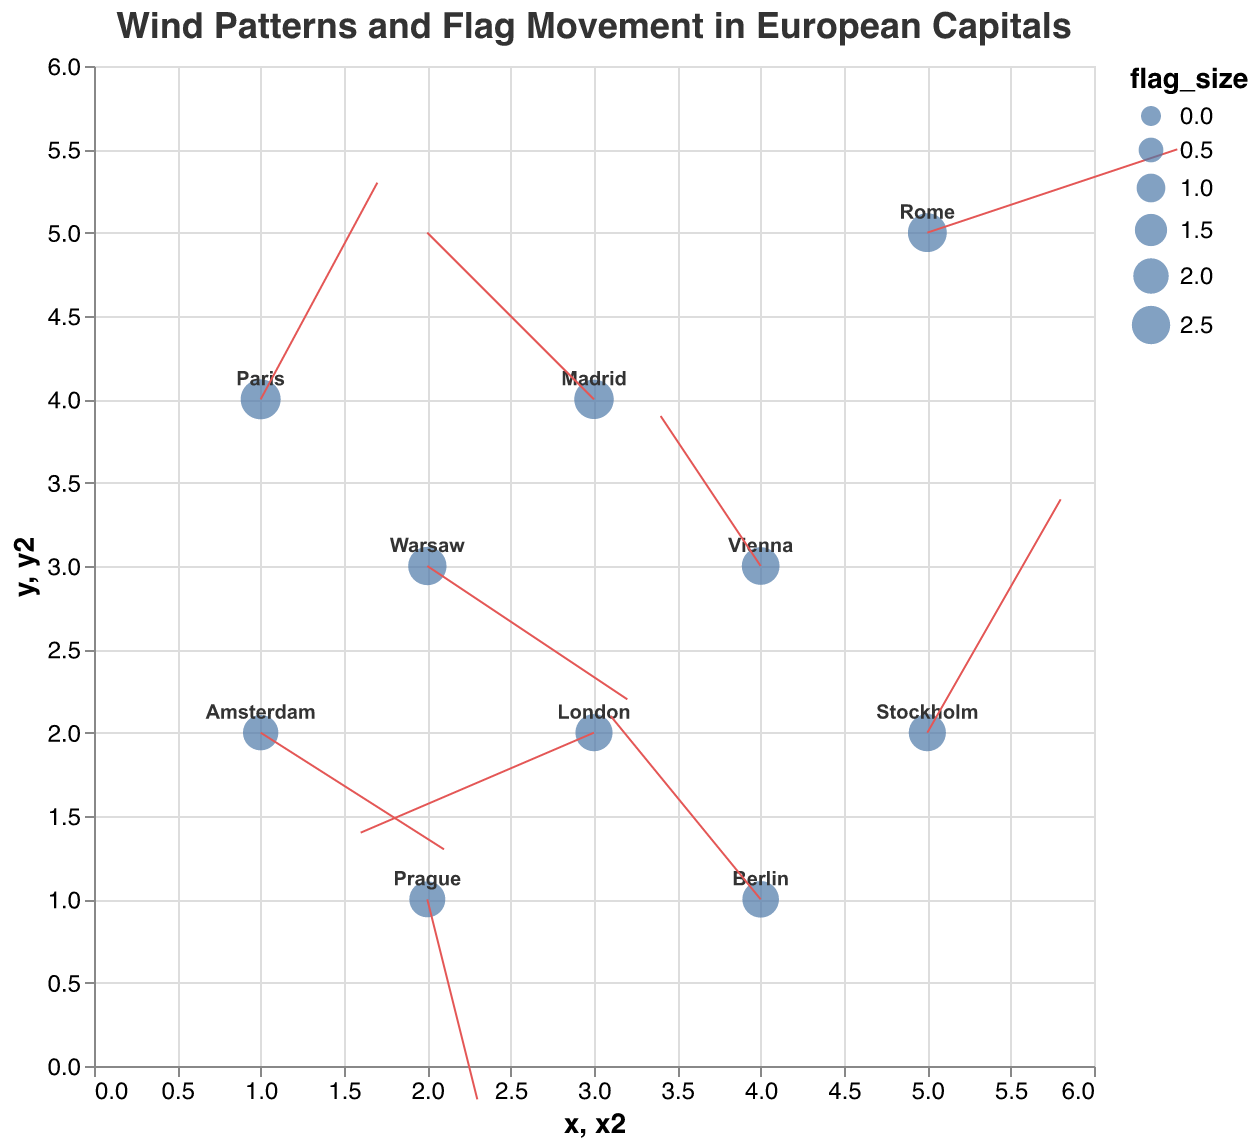What is the title of the plot? The title is located at the top of the plot and is written in bold, larger font. It states the main subject of the visualization.
Answer: Wind Patterns and Flag Movement in European Capitals Which city has the largest flag size? The size of the flags can be interpreted by the size of the points on the plot. The largest point corresponds to Paris.
Answer: Paris Describe the wind direction in London based on the plot. The direction of the wind in London can be gauged by the red arrow originating from the city's point. The arrow shows a negative x-component and a negative y-component, indicating a southwestward direction.
Answer: Southwest What is the average flag size of all the cities? To find this, sum up the flag sizes of all cities and then divide by the number of cities. The flag sizes are 2.5, 2.2, 2.8, 2.3, 2.6, 2.1, 2.4, 2.0, 2.7, and 2.3. The sum is 24.9. Divide by 10.
Answer: 2.49 Which city experiences the strongest westward wind component? To find this, look at the x-components of all wind vectors, picking the most negative value since westward is negative x-direction. The most negative value is from London with -1.4.
Answer: London Compare the wind patterns in Berlin and Vienna. Which city has a stronger vertical wind component? Compare the absolute values of the v-components for Berlin and Vienna. Berlin's v-component is 1.1 and Vienna's is 0.9. Berlin has the stronger vertical component.
Answer: Berlin What is the direction of wind in Madrid? Examine the red arrow at Madrid's location. The x-component is negative and the y-component is positive, indicating a northwestward direction.
Answer: Northwest Which city’s flag movement is represented along the line between x=2 and x=3? Locate the points along x=2 to x=3 on the x-axis. Only Warsaw lies in this range and has its red arrow extending to around x=3.
Answer: Warsaw Identify the city with the smallest flag size and describe its wind vector. The smallest point signifies the smallest flag size, which is in Amsterdam. Its wind vector has a positive x-component and a negative y-component, indicating a southeastward direction.
Answer: Amsterdam 